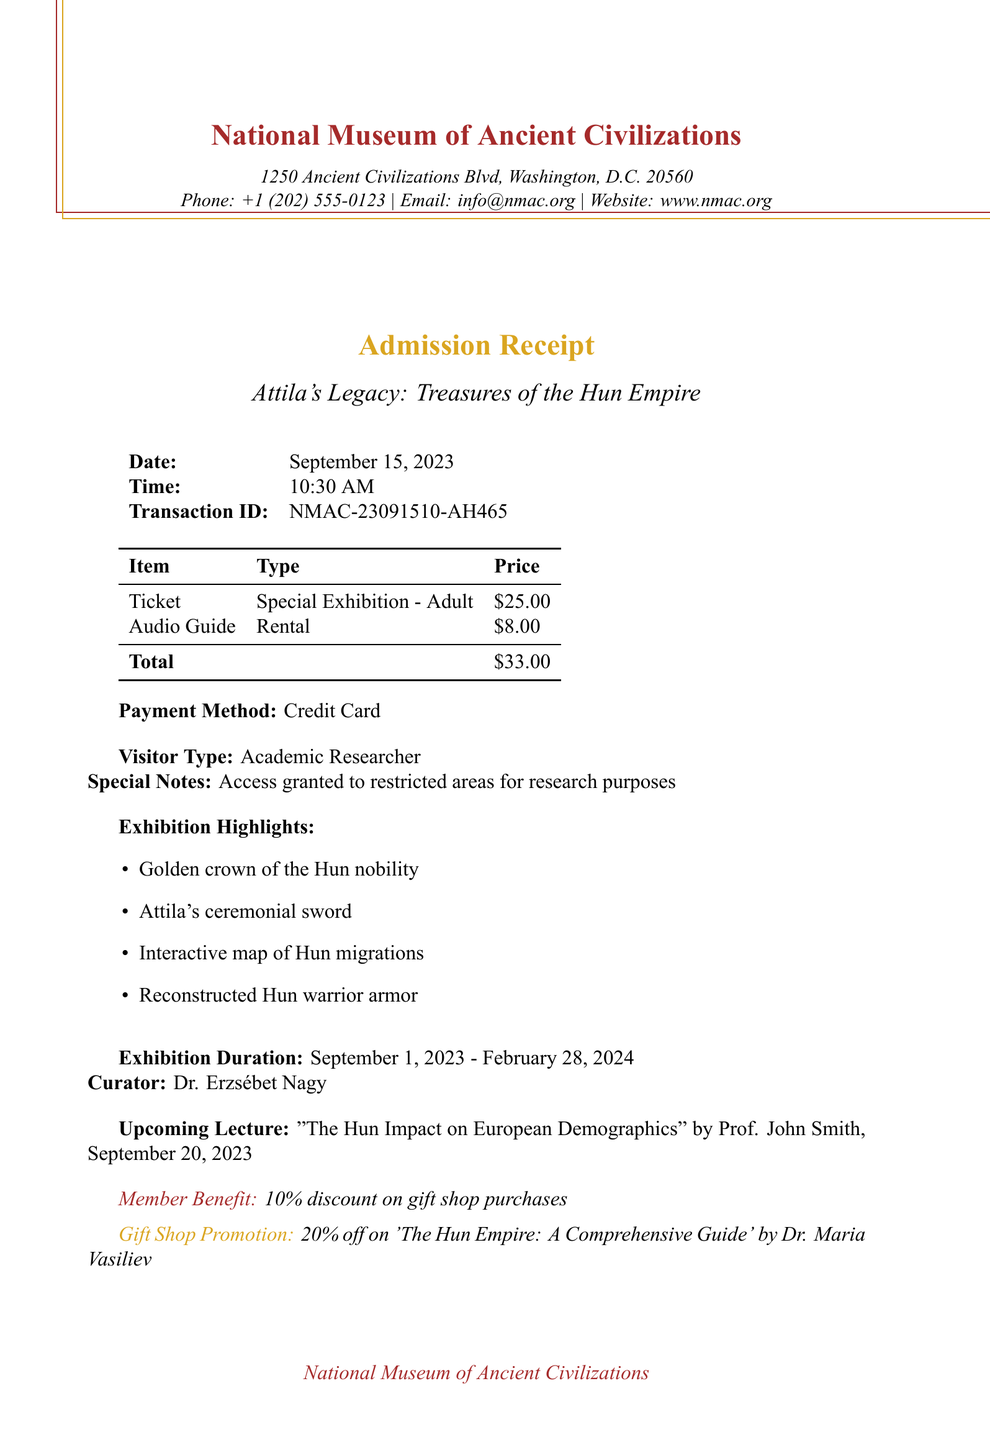What is the name of the museum? The name of the museum is mentioned at the top of the receipt.
Answer: National Museum of Ancient Civilizations What is the total amount paid? The total amount paid is specified in the table at the bottom of the receipt.
Answer: $33.00 Who is the curator of the exhibition? The curator of the exhibition is listed towards the end of the receipt.
Answer: Dr. Erzsébet Nagy What was the ticket price for the special exhibition? The ticket price for the special exhibition is mentioned in the itemized list.
Answer: $25.00 When does the exhibition run until? The end date of the exhibition is provided in the exhibition duration section.
Answer: February 28, 2024 What type of visitor is registered? The visitor type is mentioned in a specific line of the document.
Answer: Academic Researcher What is the upcoming lecture topic? The topic of the upcoming lecture is stated towards the end of the receipt.
Answer: The Hun Impact on European Demographics What discount do members receive on gift shop purchases? The member benefits specifically state the discount available.
Answer: 10% discount What is the audio guide rental price? The audio guide rental price is indicated in the itemized pricing table.
Answer: $8.00 